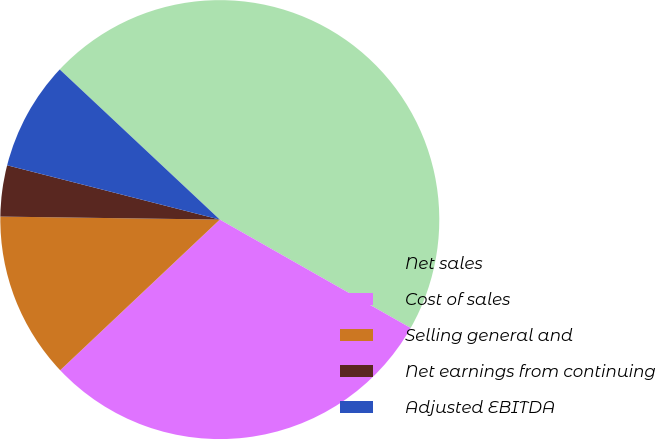<chart> <loc_0><loc_0><loc_500><loc_500><pie_chart><fcel>Net sales<fcel>Cost of sales<fcel>Selling general and<fcel>Net earnings from continuing<fcel>Adjusted EBITDA<nl><fcel>46.23%<fcel>29.74%<fcel>12.26%<fcel>3.76%<fcel>8.01%<nl></chart> 